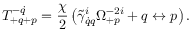<formula> <loc_0><loc_0><loc_500><loc_500>T _ { + q + p } ^ { - \dot { q } } = \frac { \chi } { 2 } \left ( \tilde { \gamma } _ { \dot { q } q } ^ { i } \Omega _ { + p } ^ { - 2 i } + q \leftrightarrow p \right ) .</formula> 